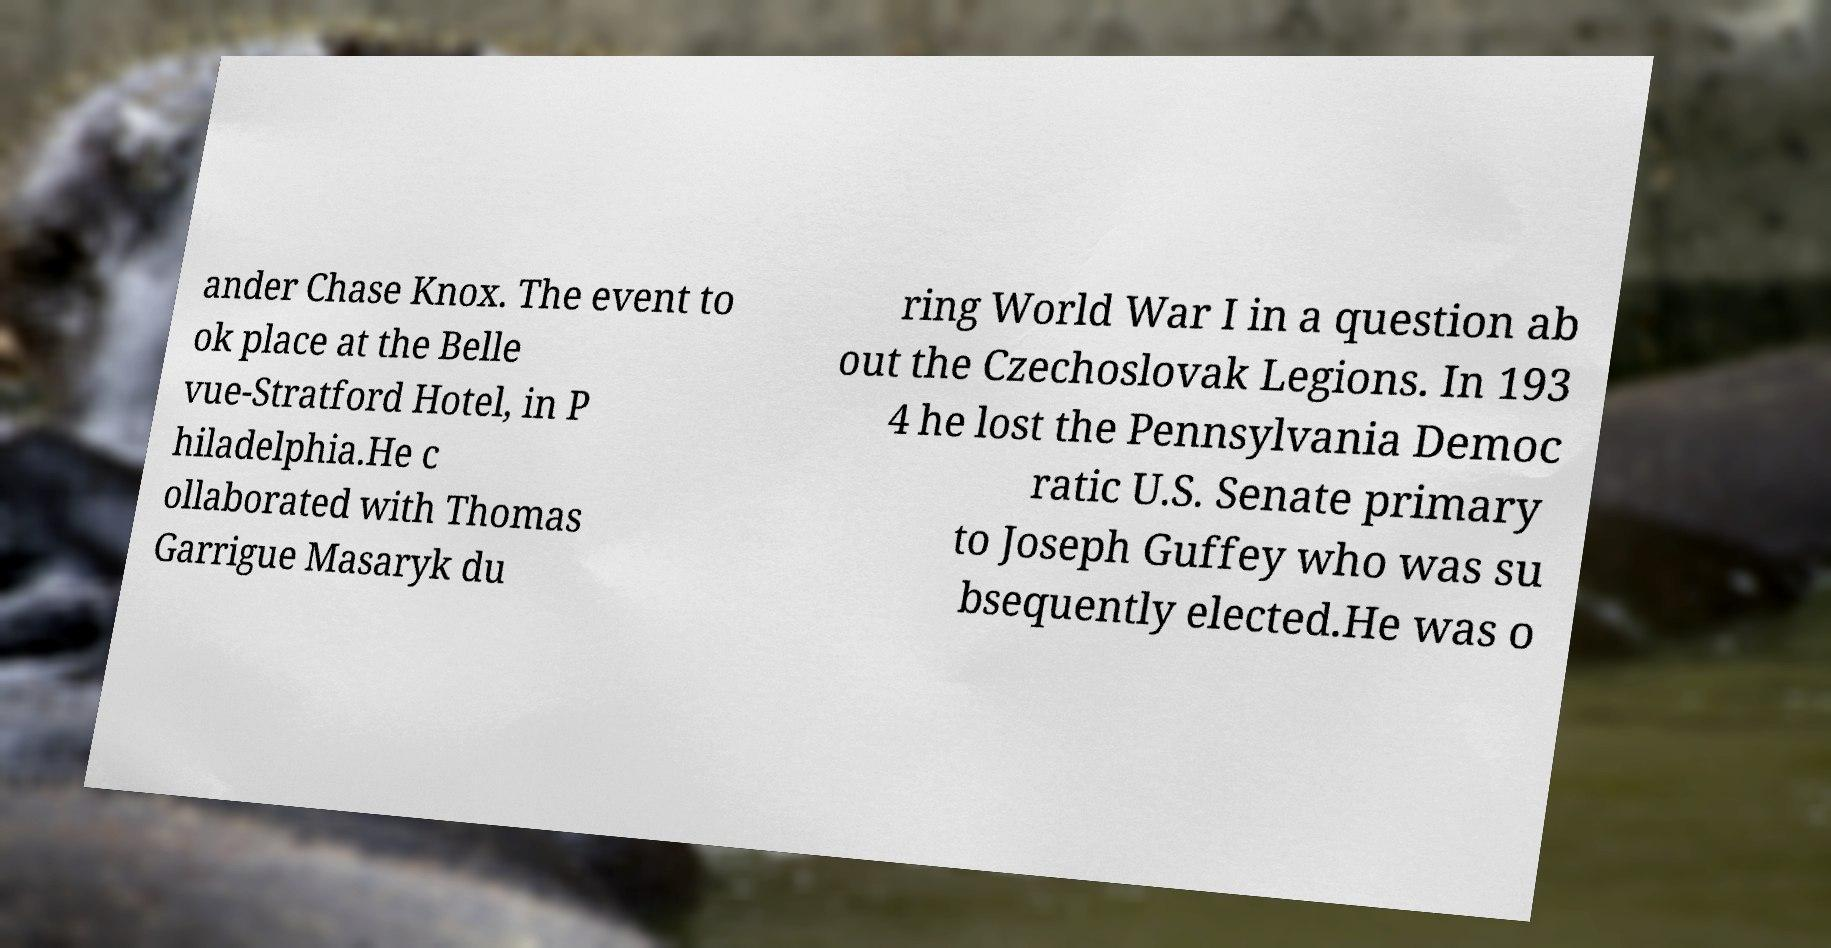Can you accurately transcribe the text from the provided image for me? ander Chase Knox. The event to ok place at the Belle vue-Stratford Hotel, in P hiladelphia.He c ollaborated with Thomas Garrigue Masaryk du ring World War I in a question ab out the Czechoslovak Legions. In 193 4 he lost the Pennsylvania Democ ratic U.S. Senate primary to Joseph Guffey who was su bsequently elected.He was o 